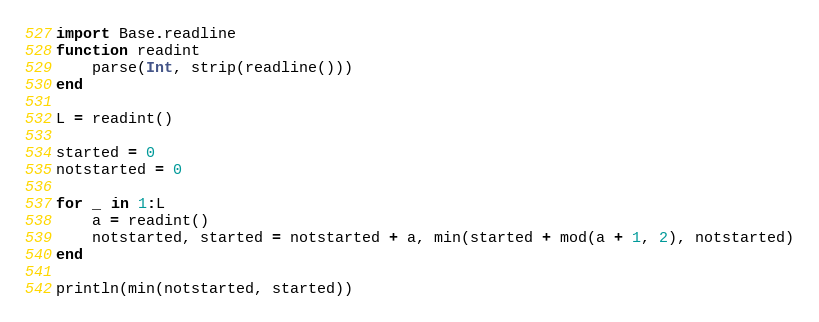Convert code to text. <code><loc_0><loc_0><loc_500><loc_500><_Julia_>import Base.readline
function readint
    parse(Int, strip(readline()))
end

L = readint()

started = 0
notstarted = 0

for _ in 1:L
    a = readint()
    notstarted, started = notstarted + a, min(started + mod(a + 1, 2), notstarted)
end

println(min(notstarted, started))</code> 